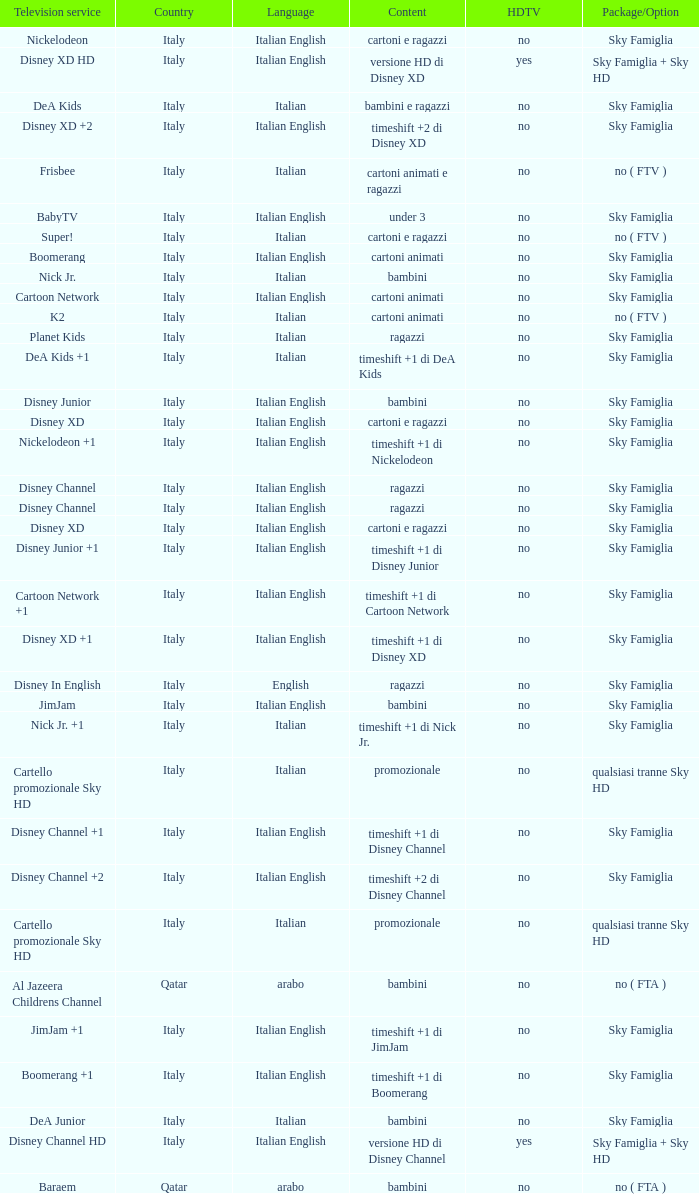Parse the full table. {'header': ['Television service', 'Country', 'Language', 'Content', 'HDTV', 'Package/Option'], 'rows': [['Nickelodeon', 'Italy', 'Italian English', 'cartoni e ragazzi', 'no', 'Sky Famiglia'], ['Disney XD HD', 'Italy', 'Italian English', 'versione HD di Disney XD', 'yes', 'Sky Famiglia + Sky HD'], ['DeA Kids', 'Italy', 'Italian', 'bambini e ragazzi', 'no', 'Sky Famiglia'], ['Disney XD +2', 'Italy', 'Italian English', 'timeshift +2 di Disney XD', 'no', 'Sky Famiglia'], ['Frisbee', 'Italy', 'Italian', 'cartoni animati e ragazzi', 'no', 'no ( FTV )'], ['BabyTV', 'Italy', 'Italian English', 'under 3', 'no', 'Sky Famiglia'], ['Super!', 'Italy', 'Italian', 'cartoni e ragazzi', 'no', 'no ( FTV )'], ['Boomerang', 'Italy', 'Italian English', 'cartoni animati', 'no', 'Sky Famiglia'], ['Nick Jr.', 'Italy', 'Italian', 'bambini', 'no', 'Sky Famiglia'], ['Cartoon Network', 'Italy', 'Italian English', 'cartoni animati', 'no', 'Sky Famiglia'], ['K2', 'Italy', 'Italian', 'cartoni animati', 'no', 'no ( FTV )'], ['Planet Kids', 'Italy', 'Italian', 'ragazzi', 'no', 'Sky Famiglia'], ['DeA Kids +1', 'Italy', 'Italian', 'timeshift +1 di DeA Kids', 'no', 'Sky Famiglia'], ['Disney Junior', 'Italy', 'Italian English', 'bambini', 'no', 'Sky Famiglia'], ['Disney XD', 'Italy', 'Italian English', 'cartoni e ragazzi', 'no', 'Sky Famiglia'], ['Nickelodeon +1', 'Italy', 'Italian English', 'timeshift +1 di Nickelodeon', 'no', 'Sky Famiglia'], ['Disney Channel', 'Italy', 'Italian English', 'ragazzi', 'no', 'Sky Famiglia'], ['Disney Channel', 'Italy', 'Italian English', 'ragazzi', 'no', 'Sky Famiglia'], ['Disney XD', 'Italy', 'Italian English', 'cartoni e ragazzi', 'no', 'Sky Famiglia'], ['Disney Junior +1', 'Italy', 'Italian English', 'timeshift +1 di Disney Junior', 'no', 'Sky Famiglia'], ['Cartoon Network +1', 'Italy', 'Italian English', 'timeshift +1 di Cartoon Network', 'no', 'Sky Famiglia'], ['Disney XD +1', 'Italy', 'Italian English', 'timeshift +1 di Disney XD', 'no', 'Sky Famiglia'], ['Disney In English', 'Italy', 'English', 'ragazzi', 'no', 'Sky Famiglia'], ['JimJam', 'Italy', 'Italian English', 'bambini', 'no', 'Sky Famiglia'], ['Nick Jr. +1', 'Italy', 'Italian', 'timeshift +1 di Nick Jr.', 'no', 'Sky Famiglia'], ['Cartello promozionale Sky HD', 'Italy', 'Italian', 'promozionale', 'no', 'qualsiasi tranne Sky HD'], ['Disney Channel +1', 'Italy', 'Italian English', 'timeshift +1 di Disney Channel', 'no', 'Sky Famiglia'], ['Disney Channel +2', 'Italy', 'Italian English', 'timeshift +2 di Disney Channel', 'no', 'Sky Famiglia'], ['Cartello promozionale Sky HD', 'Italy', 'Italian', 'promozionale', 'no', 'qualsiasi tranne Sky HD'], ['Al Jazeera Childrens Channel', 'Qatar', 'arabo', 'bambini', 'no', 'no ( FTA )'], ['JimJam +1', 'Italy', 'Italian English', 'timeshift +1 di JimJam', 'no', 'Sky Famiglia'], ['Boomerang +1', 'Italy', 'Italian English', 'timeshift +1 di Boomerang', 'no', 'Sky Famiglia'], ['DeA Junior', 'Italy', 'Italian', 'bambini', 'no', 'Sky Famiglia'], ['Disney Channel HD', 'Italy', 'Italian English', 'versione HD di Disney Channel', 'yes', 'Sky Famiglia + Sky HD'], ['Baraem', 'Qatar', 'arabo', 'bambini', 'no', 'no ( FTA )']]} What is the Country when the language is italian english, and the television service is disney xd +1? Italy. 